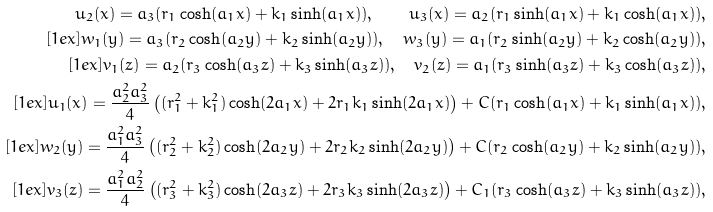<formula> <loc_0><loc_0><loc_500><loc_500>u _ { 2 } ( x ) = a _ { 3 } ( r _ { 1 } \cosh ( a _ { 1 } x ) + k _ { 1 } \sinh ( a _ { 1 } x ) ) , \quad u _ { 3 } ( x ) = a _ { 2 } ( r _ { 1 } \sinh ( a _ { 1 } x ) + k _ { 1 } \cosh ( a _ { 1 } x ) ) , \\ [ 1 e x ] w _ { 1 } ( y ) = a _ { 3 } ( r _ { 2 } \cosh ( a _ { 2 } y ) + k _ { 2 } \sinh ( a _ { 2 } y ) ) , \quad w _ { 3 } ( y ) = a _ { 1 } ( r _ { 2 } \sinh ( a _ { 2 } y ) + k _ { 2 } \cosh ( a _ { 2 } y ) ) , \\ [ 1 e x ] v _ { 1 } ( z ) = a _ { 2 } ( r _ { 3 } \cosh ( a _ { 3 } z ) + k _ { 3 } \sinh ( a _ { 3 } z ) ) , \quad v _ { 2 } ( z ) = a _ { 1 } ( r _ { 3 } \sinh ( a _ { 3 } z ) + k _ { 3 } \cosh ( a _ { 3 } z ) ) , \\ [ 1 e x ] u _ { 1 } ( x ) = \frac { a _ { 2 } ^ { 2 } a _ { 3 } ^ { 2 } } 4 \left ( ( r _ { 1 } ^ { 2 } + k _ { 1 } ^ { 2 } ) \cosh ( 2 a _ { 1 } x ) + 2 r _ { 1 } k _ { 1 } \sinh ( 2 a _ { 1 } x ) \right ) + C ( r _ { 1 } \cosh ( a _ { 1 } x ) + k _ { 1 } \sinh ( a _ { 1 } x ) ) , \\ [ 1 e x ] w _ { 2 } ( y ) = \frac { a _ { 1 } ^ { 2 } a _ { 3 } ^ { 2 } } 4 \left ( ( r _ { 2 } ^ { 2 } + k _ { 2 } ^ { 2 } ) \cosh ( 2 a _ { 2 } y ) + 2 r _ { 2 } k _ { 2 } \sinh ( 2 a _ { 2 } y ) \right ) + C ( r _ { 2 } \cosh ( a _ { 2 } y ) + k _ { 2 } \sinh ( a _ { 2 } y ) ) , \\ [ 1 e x ] v _ { 3 } ( z ) = \frac { a _ { 1 } ^ { 2 } a _ { 2 } ^ { 2 } } 4 \left ( ( r _ { 3 } ^ { 2 } + k _ { 3 } ^ { 2 } ) \cosh ( 2 a _ { 3 } z ) + 2 r _ { 3 } k _ { 3 } \sinh ( 2 a _ { 3 } z ) \right ) + C _ { 1 } ( r _ { 3 } \cosh ( a _ { 3 } z ) + k _ { 3 } \sinh ( a _ { 3 } z ) ) ,</formula> 